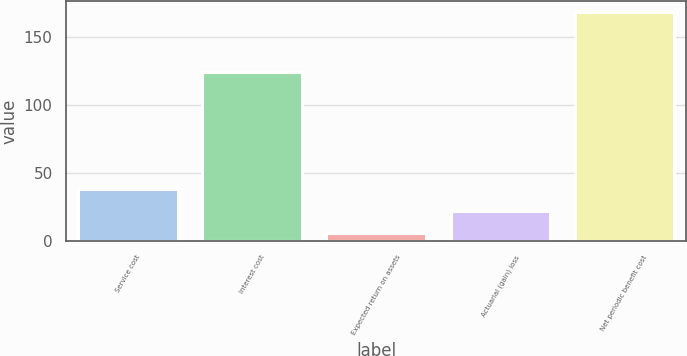Convert chart to OTSL. <chart><loc_0><loc_0><loc_500><loc_500><bar_chart><fcel>Service cost<fcel>Interest cost<fcel>Expected return on assets<fcel>Actuarial (gain) loss<fcel>Net periodic benefit cost<nl><fcel>38.4<fcel>124<fcel>6<fcel>22.2<fcel>168<nl></chart> 